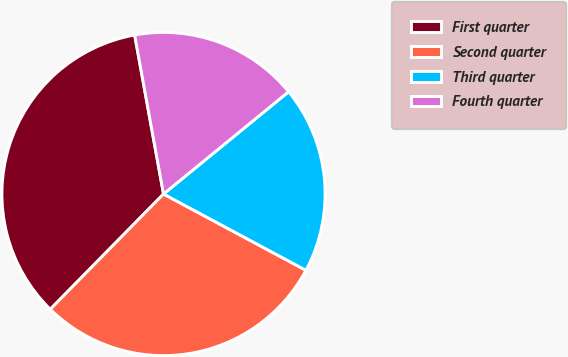<chart> <loc_0><loc_0><loc_500><loc_500><pie_chart><fcel>First quarter<fcel>Second quarter<fcel>Third quarter<fcel>Fourth quarter<nl><fcel>34.78%<fcel>29.53%<fcel>18.73%<fcel>16.95%<nl></chart> 